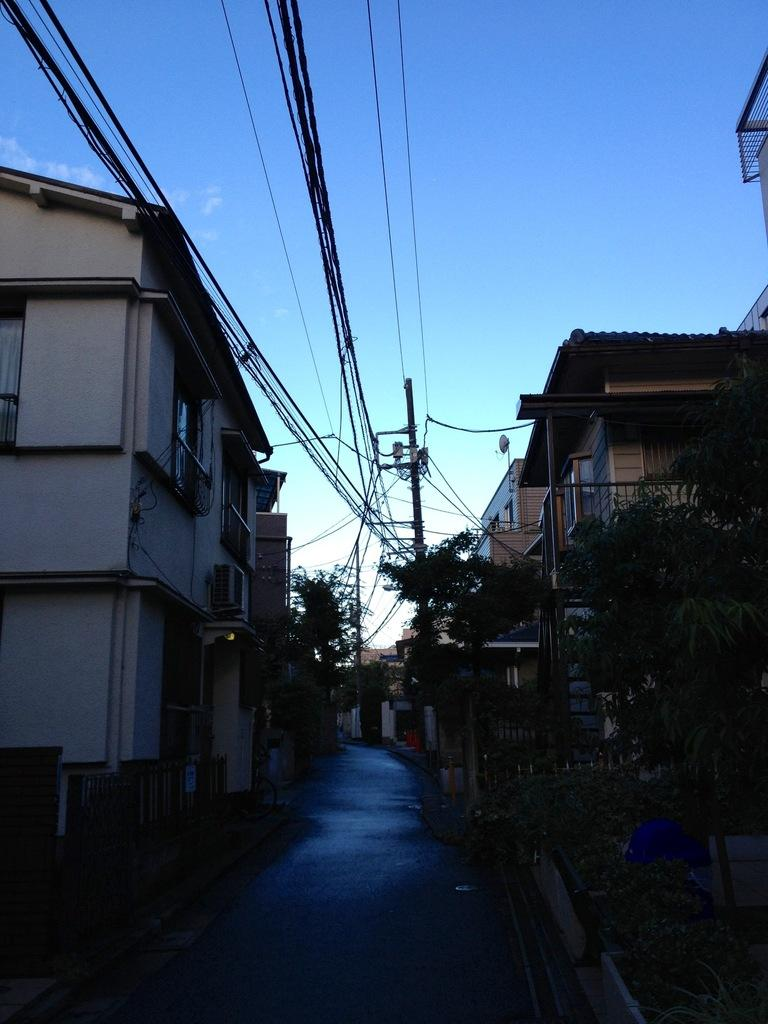What is the main feature in the middle of the image? There is a road in the middle of the image. What can be seen on either side of the road? There are houses on either side of the road. What color is the sky in the image? The sky is blue in color. Can you see any ants carrying yams along the railway in the image? There is no railway, ants, or yams present in the image. 